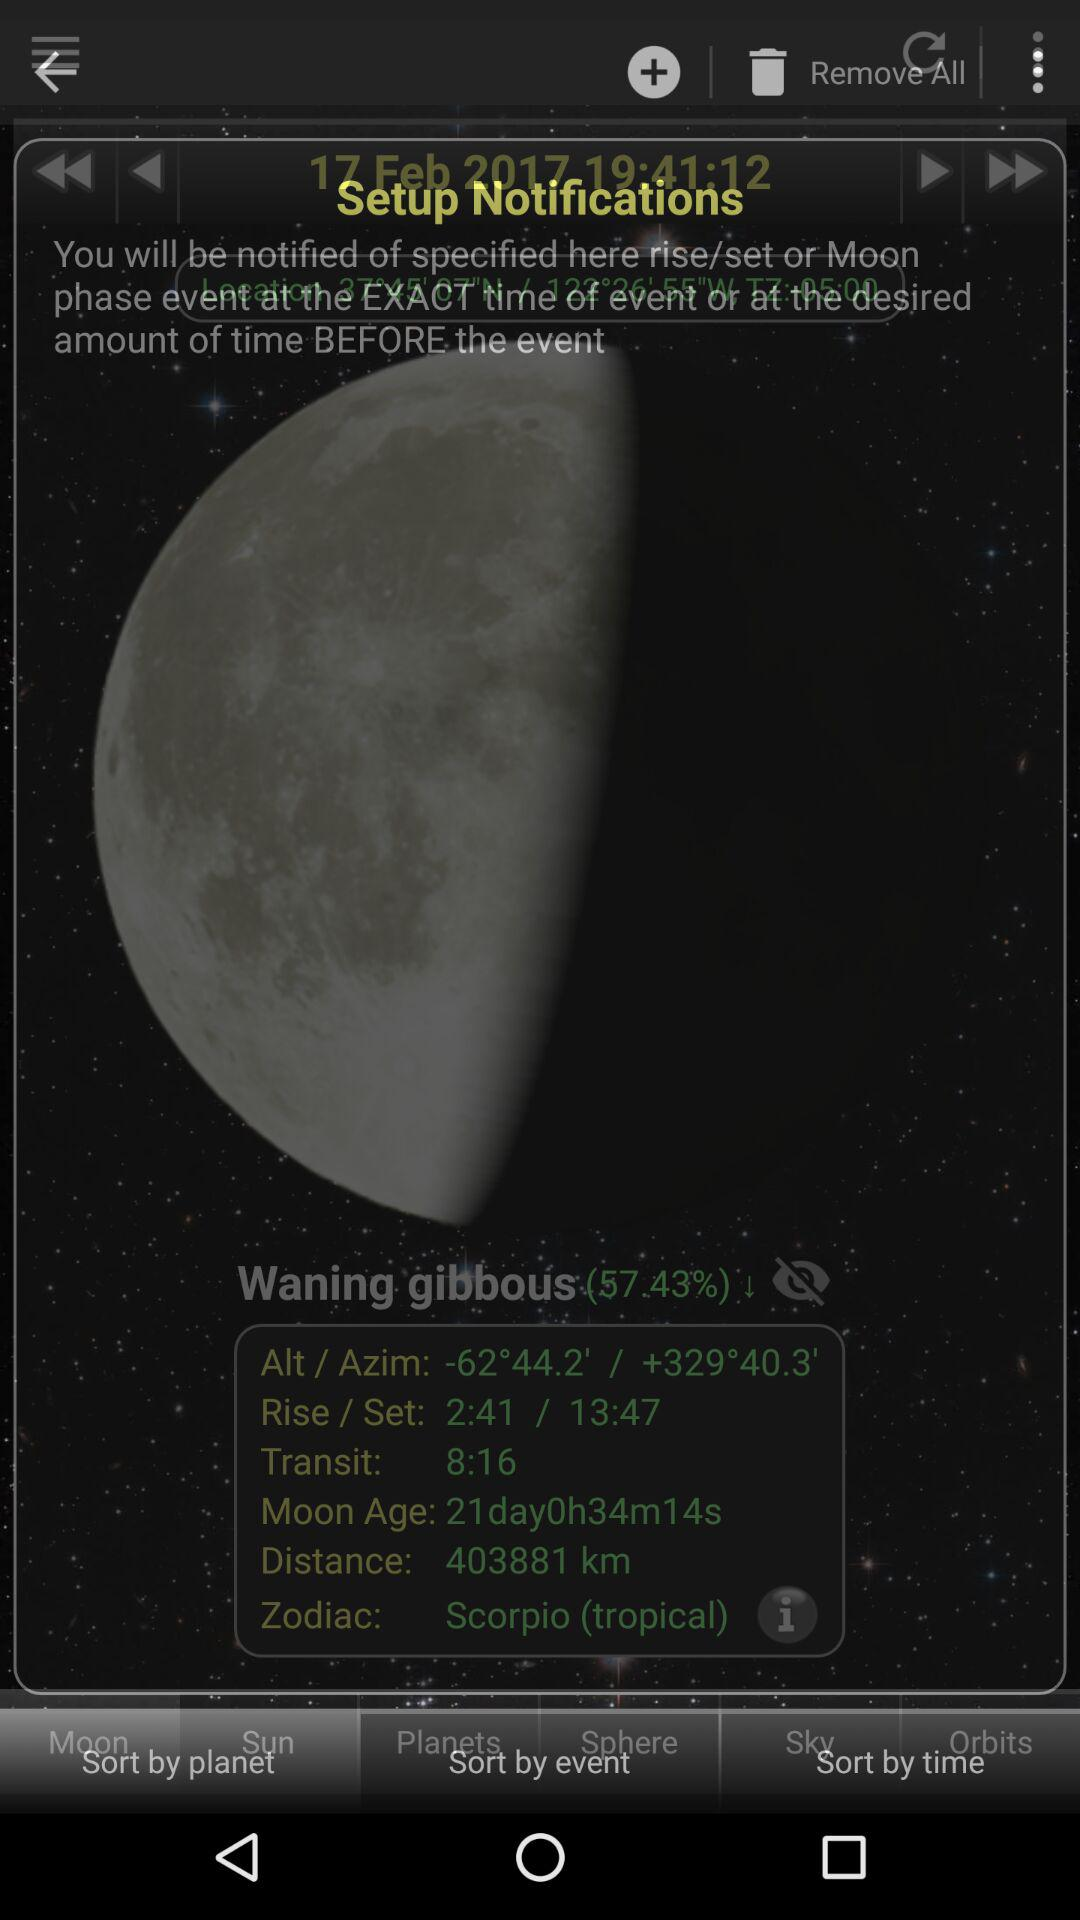What is the transit time? The transit time is 8:16. 